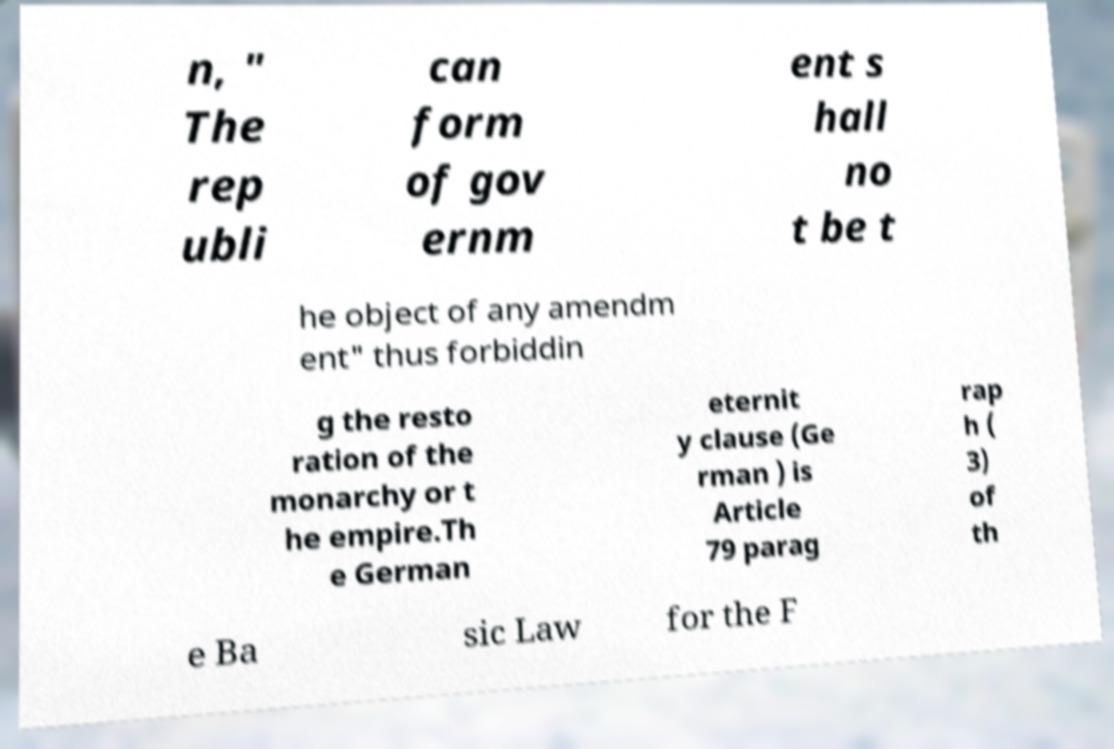Please identify and transcribe the text found in this image. n, " The rep ubli can form of gov ernm ent s hall no t be t he object of any amendm ent" thus forbiddin g the resto ration of the monarchy or t he empire.Th e German eternit y clause (Ge rman ) is Article 79 parag rap h ( 3) of th e Ba sic Law for the F 